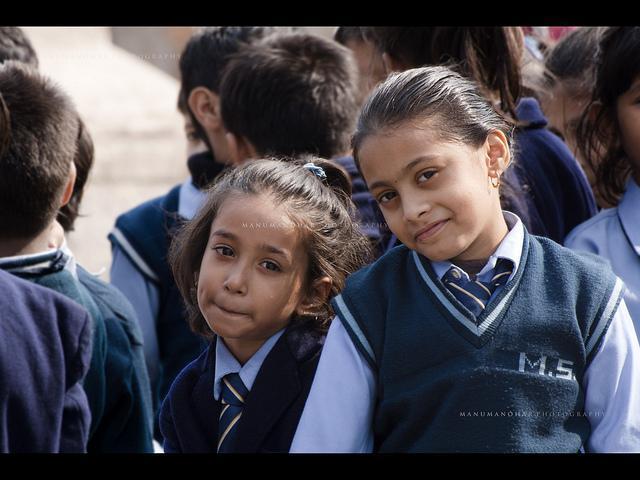How many people are there?
Give a very brief answer. 9. 